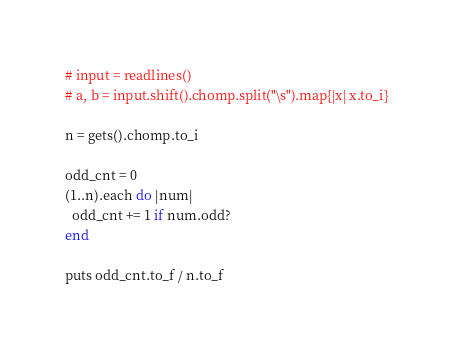Convert code to text. <code><loc_0><loc_0><loc_500><loc_500><_Ruby_># input = readlines()
# a, b = input.shift().chomp.split("\s").map{|x| x.to_i}

n = gets().chomp.to_i

odd_cnt = 0
(1..n).each do |num|
  odd_cnt += 1 if num.odd?
end

puts odd_cnt.to_f / n.to_f
</code> 